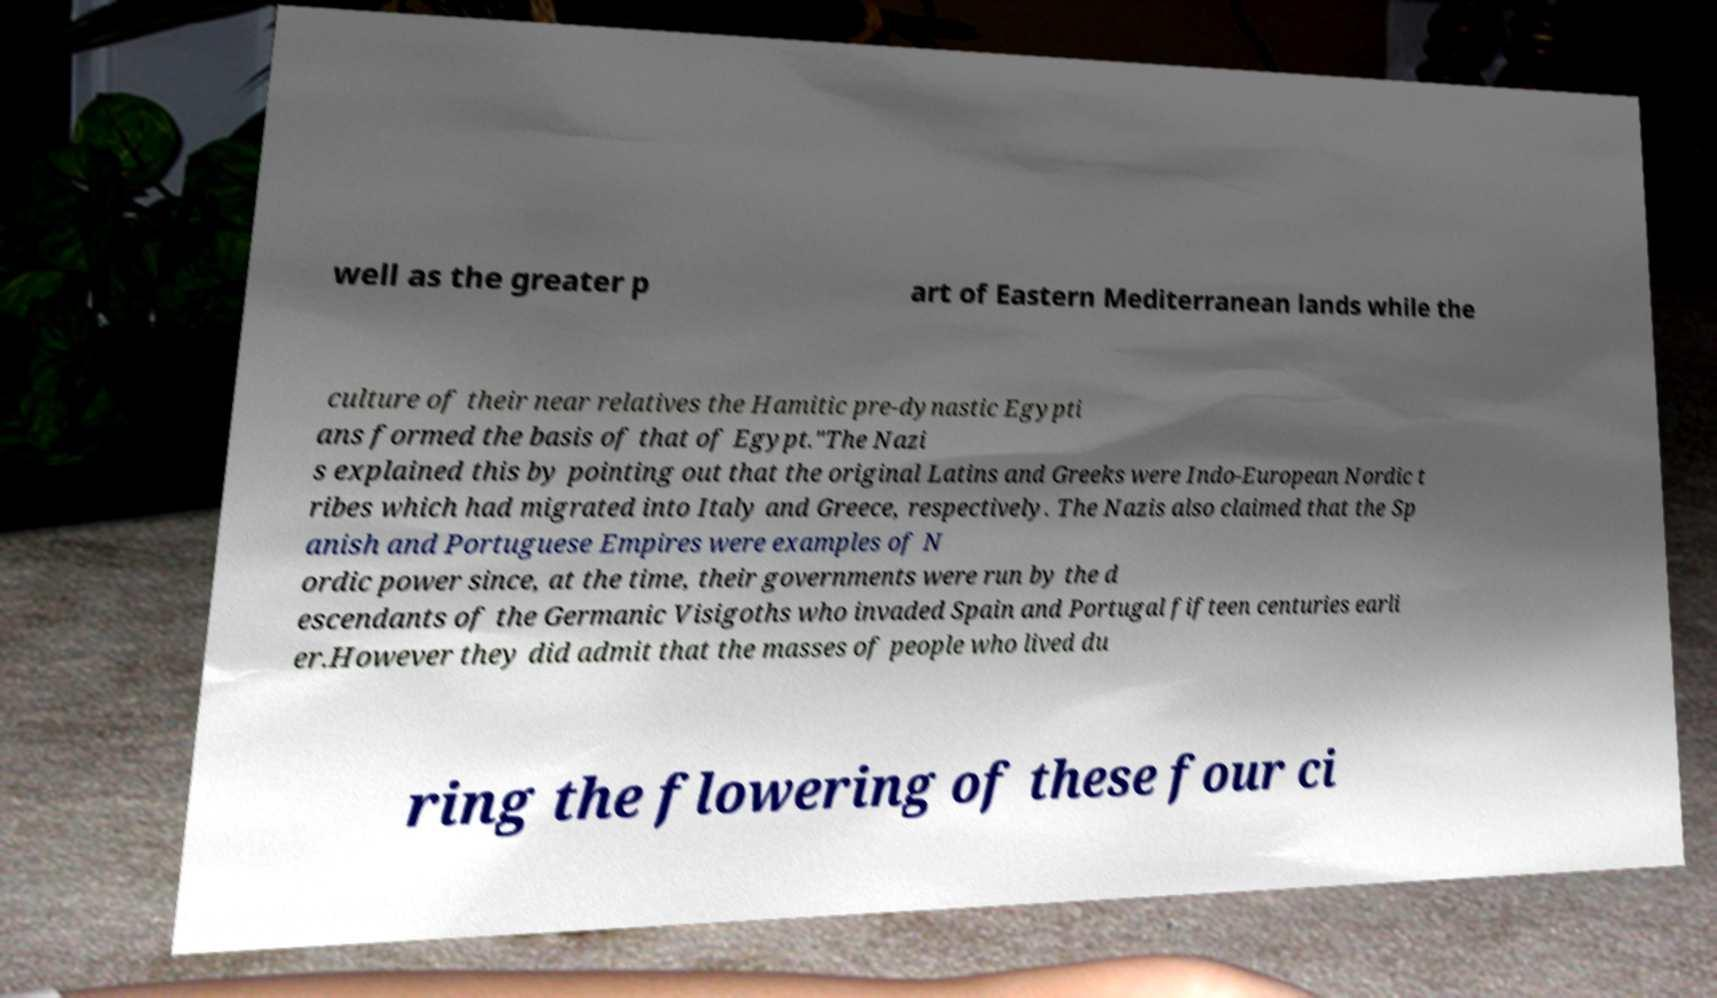Can you accurately transcribe the text from the provided image for me? well as the greater p art of Eastern Mediterranean lands while the culture of their near relatives the Hamitic pre-dynastic Egypti ans formed the basis of that of Egypt."The Nazi s explained this by pointing out that the original Latins and Greeks were Indo-European Nordic t ribes which had migrated into Italy and Greece, respectively. The Nazis also claimed that the Sp anish and Portuguese Empires were examples of N ordic power since, at the time, their governments were run by the d escendants of the Germanic Visigoths who invaded Spain and Portugal fifteen centuries earli er.However they did admit that the masses of people who lived du ring the flowering of these four ci 